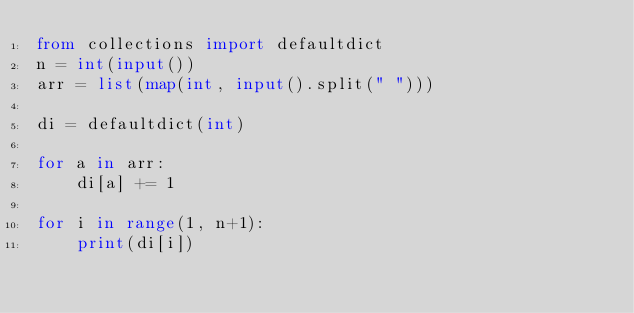<code> <loc_0><loc_0><loc_500><loc_500><_Python_>from collections import defaultdict
n = int(input())
arr = list(map(int, input().split(" ")))

di = defaultdict(int)

for a in arr:
    di[a] += 1

for i in range(1, n+1):
    print(di[i])</code> 